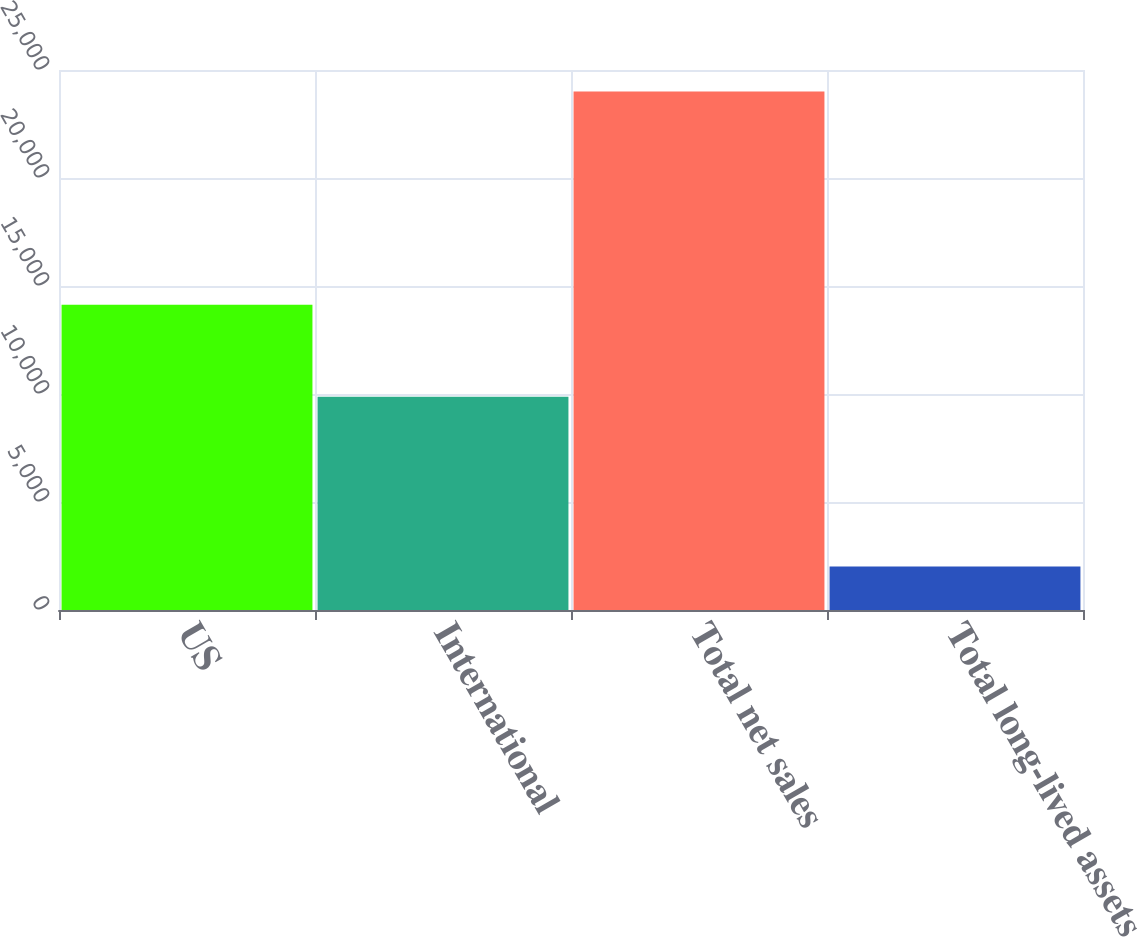Convert chart to OTSL. <chart><loc_0><loc_0><loc_500><loc_500><bar_chart><fcel>US<fcel>International<fcel>Total net sales<fcel>Total long-lived assets<nl><fcel>14128<fcel>9878<fcel>24006<fcel>2012<nl></chart> 